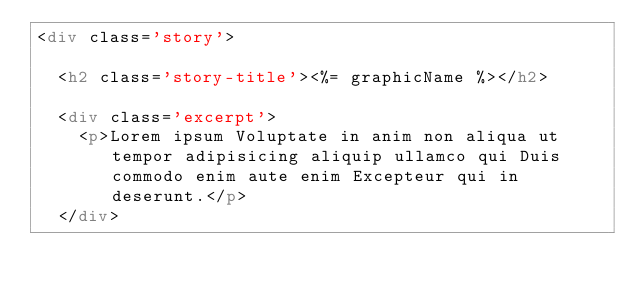<code> <loc_0><loc_0><loc_500><loc_500><_HTML_><div class='story'>

	<h2 class='story-title'><%= graphicName %></h2>

	<div class='excerpt'>
		<p>Lorem ipsum Voluptate in anim non aliqua ut tempor adipisicing aliquip ullamco qui Duis commodo enim aute enim Excepteur qui in deserunt.</p>
	</div>
</code> 